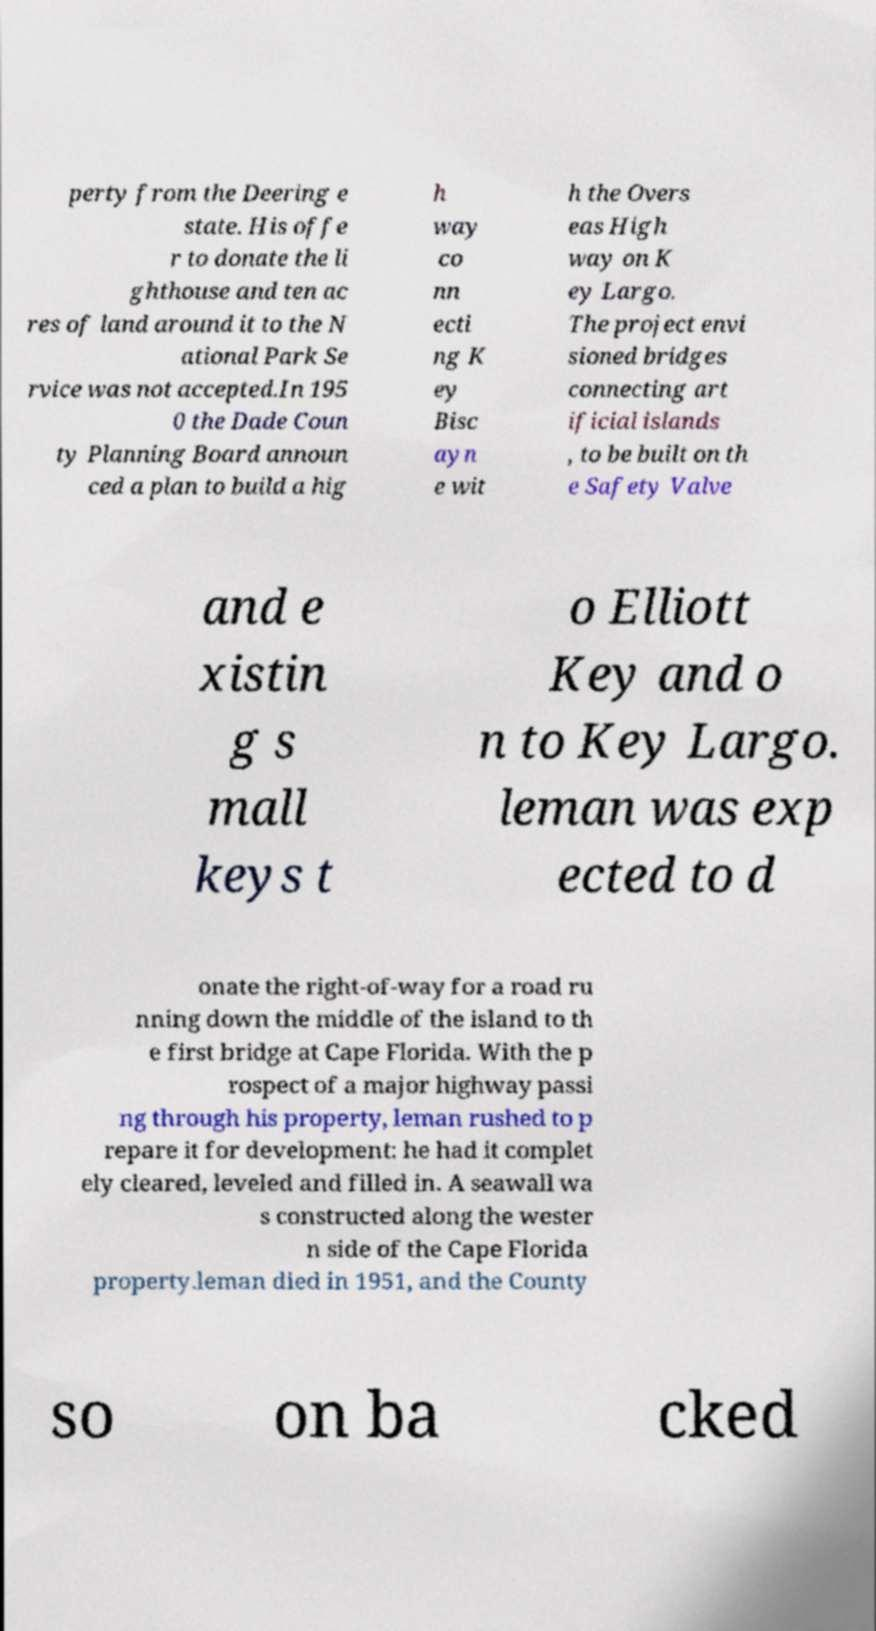Please identify and transcribe the text found in this image. perty from the Deering e state. His offe r to donate the li ghthouse and ten ac res of land around it to the N ational Park Se rvice was not accepted.In 195 0 the Dade Coun ty Planning Board announ ced a plan to build a hig h way co nn ecti ng K ey Bisc ayn e wit h the Overs eas High way on K ey Largo. The project envi sioned bridges connecting art ificial islands , to be built on th e Safety Valve and e xistin g s mall keys t o Elliott Key and o n to Key Largo. leman was exp ected to d onate the right-of-way for a road ru nning down the middle of the island to th e first bridge at Cape Florida. With the p rospect of a major highway passi ng through his property, leman rushed to p repare it for development: he had it complet ely cleared, leveled and filled in. A seawall wa s constructed along the wester n side of the Cape Florida property.leman died in 1951, and the County so on ba cked 